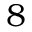Convert formula to latex. <formula><loc_0><loc_0><loc_500><loc_500>8</formula> 